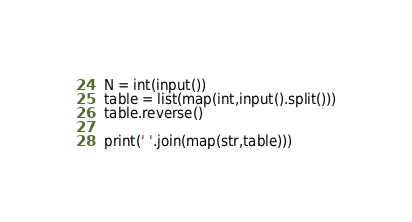<code> <loc_0><loc_0><loc_500><loc_500><_Python_>N = int(input())
table = list(map(int,input().split()))
table.reverse()

print(' '.join(map(str,table)))

</code> 